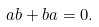<formula> <loc_0><loc_0><loc_500><loc_500>a b + b a = 0 .</formula> 